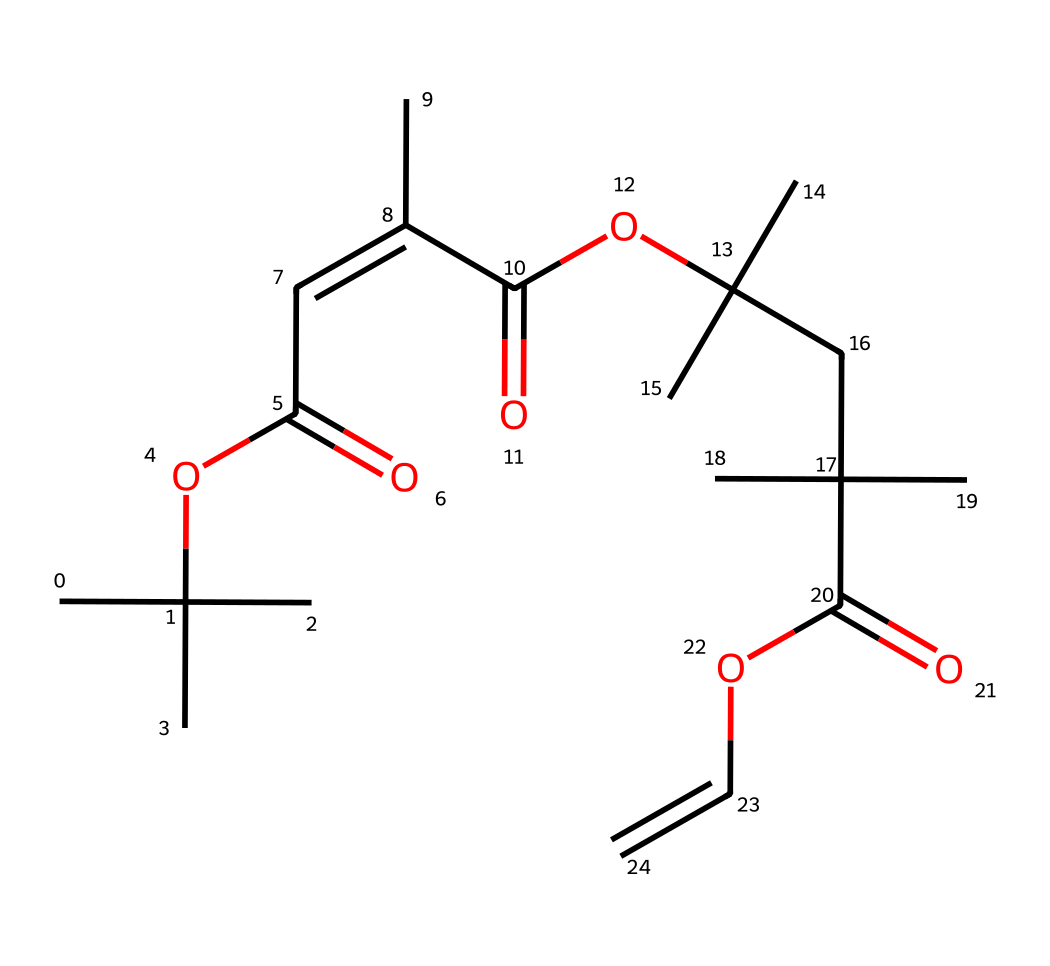What is the total number of carbon atoms in this molecule? To determine the total number of carbon atoms, we can count each carbon atom represented in the SMILES notation. In the given SMILES, there are several branches and chains, and upon counting, there are 18 carbon atoms present in total.
Answer: 18 How many double bonds are present in the structure? Analyzing the SMILES notation, we identify the presence of double bonds, which are indicated by the '=' symbol. Counting these representations reveals that there are 3 double bonds in the molecule.
Answer: 3 What functional groups are present in this photoresist? Since the molecule contains 'OC(=O)' segments, we recognize these as ester functional groups. This is relevant as it indicates the presence of esters, which are common in photoresists. Besides esters, we observe alkenes due to the presence of 'C=C' links.
Answer: esters and alkenes Is this compound likely to be a positive or negative photoresist? The presence of the ester and alkene groups suggests that this compound has characteristics aligned with negative photoresists, which typically cross-link upon exposure to light, indicating a darker coloration in the areas that were exposed.
Answer: negative What is the longest continuous carbon chain in the molecule? By inspecting the structure and following the longest uninterrupted chain of carbon atoms in the SMILES notation, we find that the longest hydrocarbon chain consists of 8 carbon atoms.
Answer: 8 What type of polymerization is this photoresist likely designed for? Since this photoresist features functionalities (like esters) conducive to cross-linking reactions upon irradiation, it is most likely designed for step-growth polymerization processes which are common in forming photoresist films.
Answer: step-growth Can this compound be used for 3D printing applications in AR technologies? Given the cross-linking nature and the ability of this type of negative photoresist to create detailed patterns, it is indeed suitable for 3D printing applications, especially in augmented reality visualizations.
Answer: yes 